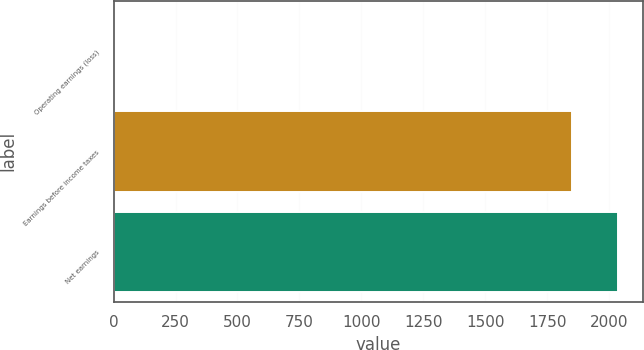Convert chart to OTSL. <chart><loc_0><loc_0><loc_500><loc_500><bar_chart><fcel>Operating earnings (loss)<fcel>Earnings before income taxes<fcel>Net earnings<nl><fcel>2.5<fcel>1848.7<fcel>2033.32<nl></chart> 